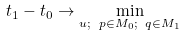Convert formula to latex. <formula><loc_0><loc_0><loc_500><loc_500>t _ { 1 } - t _ { 0 } \rightarrow \underset { u ; \ p \in M _ { 0 } ; \ q \in M _ { 1 } } { \min }</formula> 